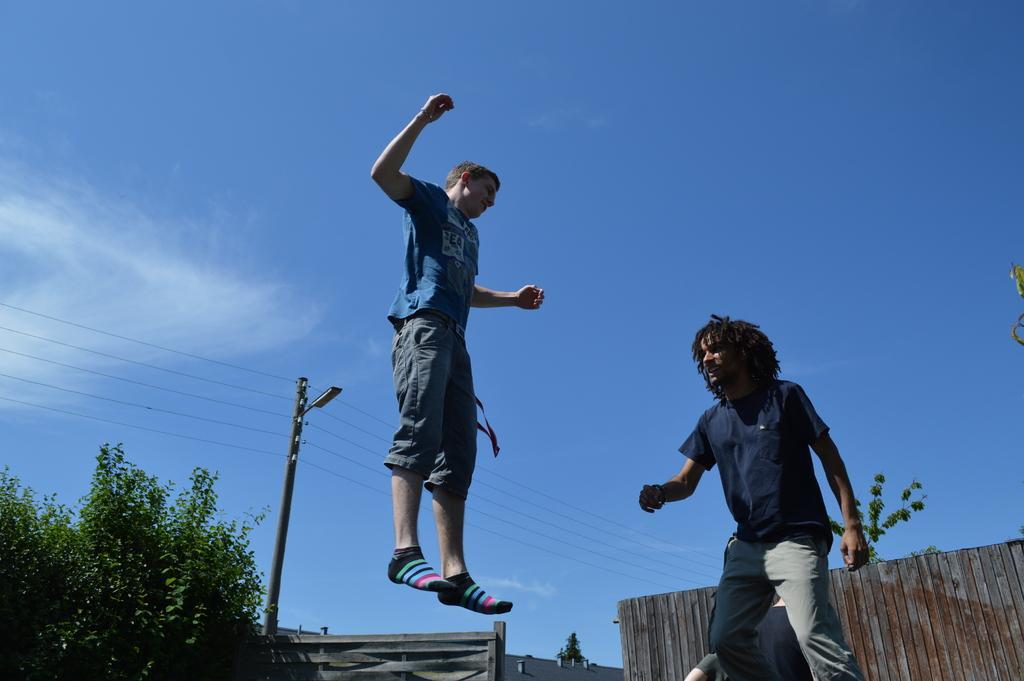How would you summarize this image in a sentence or two? In this image in the foreground there are two persons visible, one person is jumping, there is a fence visible in the bottom right, behind the fence there is a tree, there is a pole, power line cable, light, tree visible at the bottom, at the top there is the sky. 